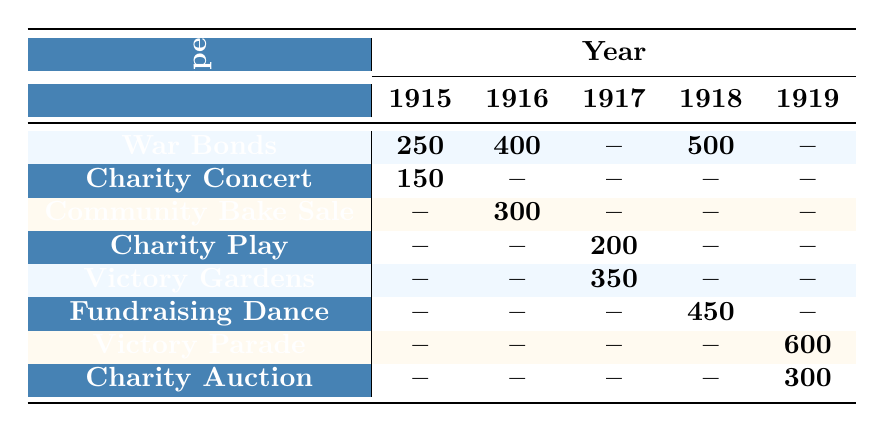What was the total participation in War Bonds during 1915 and 1918? The participation in War Bonds in 1915 is 250, and in 1918, it is 500. Adding both values gives 250 + 500 = 750.
Answer: 750 Which event had the highest participation in 1919? The only events listed for 1919 are Victory Parade with 600 participants and Charity Auction with 300 participants. Therefore, the highest participation is for the Victory Parade with 600 participants.
Answer: 600 Did the Charity Concert occur in 1917? In the table, Charity Concert is listed only in 1915 with 150 participants. There are no entries for Charity Concert in 1917, so the statement is false.
Answer: No What event had the least participation in 1916? The events in 1916 are Community Bake Sale with 300 and War Bonds with 400. Since no other events are listed for that year, Community Bake Sale has the least participation at 300.
Answer: 300 What is the total participation across all events in 1917? The events in 1917 are Charity Play (200) and Victory Gardens (350). Summing both gives 200 + 350 = 550 for a total participation of 550.
Answer: 550 